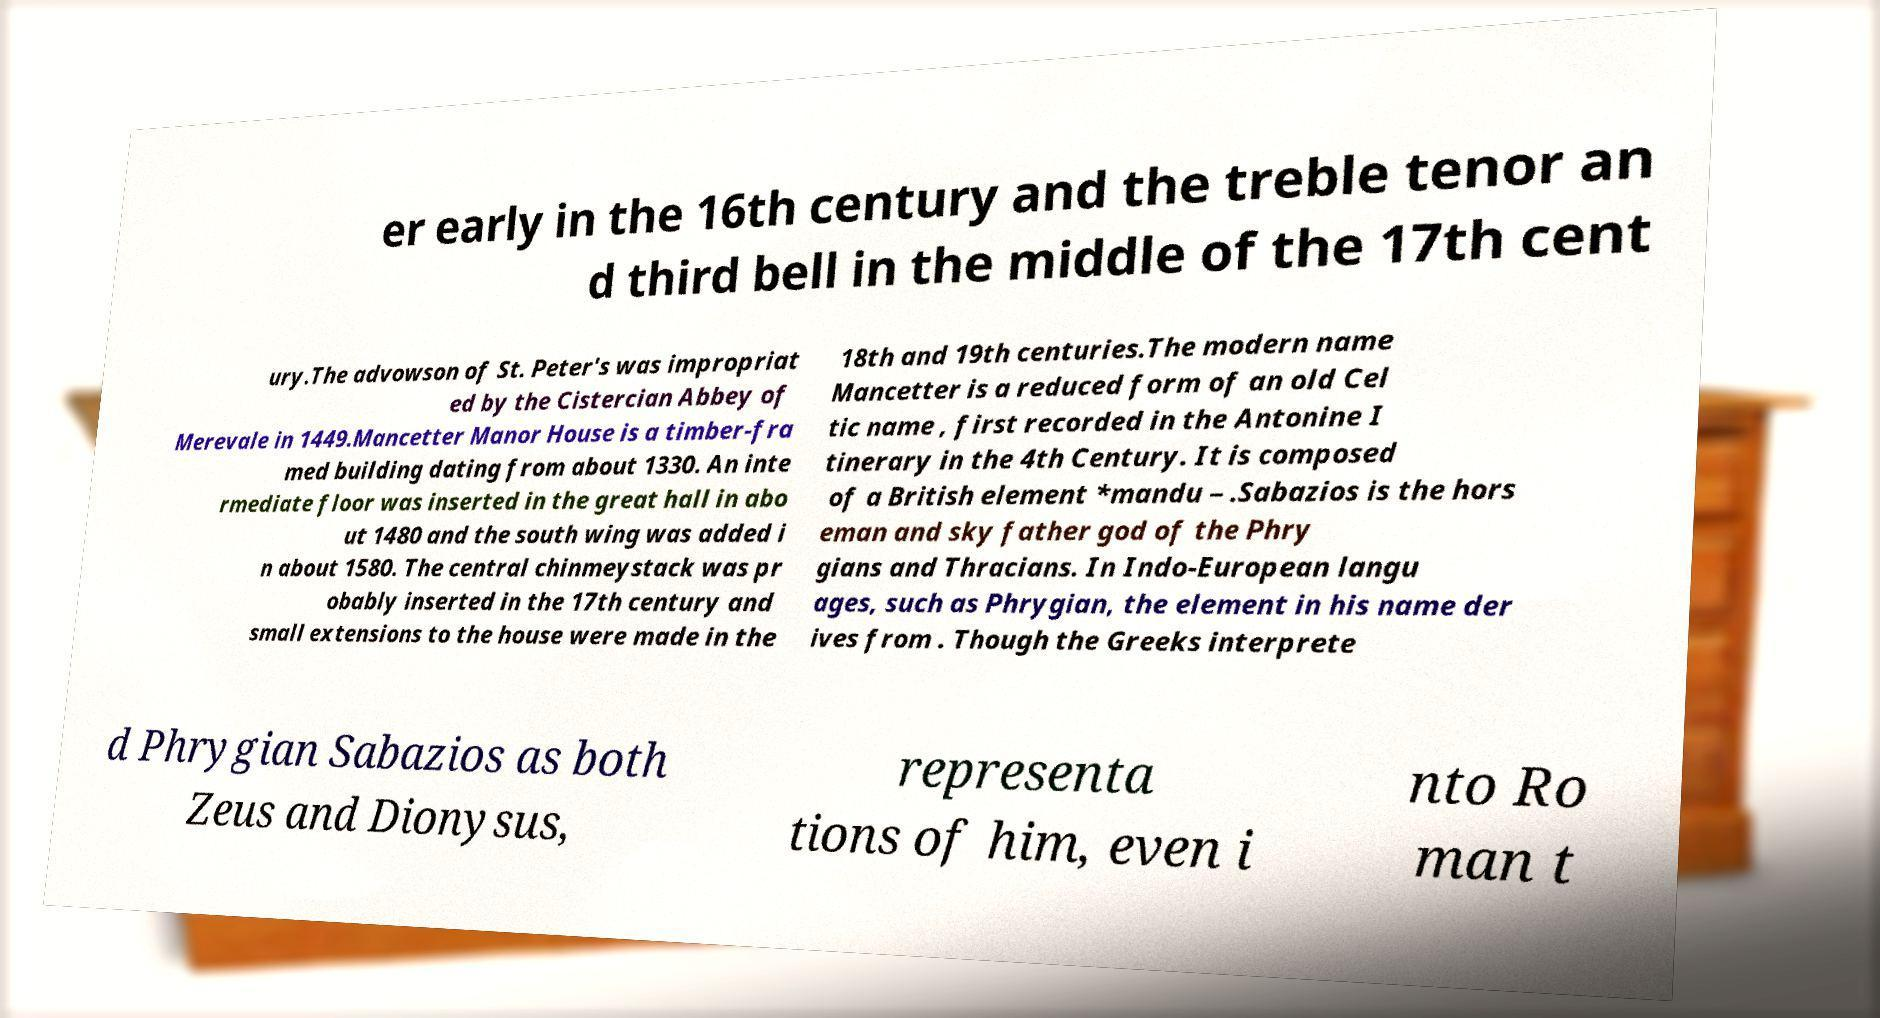I need the written content from this picture converted into text. Can you do that? er early in the 16th century and the treble tenor an d third bell in the middle of the 17th cent ury.The advowson of St. Peter's was impropriat ed by the Cistercian Abbey of Merevale in 1449.Mancetter Manor House is a timber-fra med building dating from about 1330. An inte rmediate floor was inserted in the great hall in abo ut 1480 and the south wing was added i n about 1580. The central chinmeystack was pr obably inserted in the 17th century and small extensions to the house were made in the 18th and 19th centuries.The modern name Mancetter is a reduced form of an old Cel tic name , first recorded in the Antonine I tinerary in the 4th Century. It is composed of a British element *mandu – .Sabazios is the hors eman and sky father god of the Phry gians and Thracians. In Indo-European langu ages, such as Phrygian, the element in his name der ives from . Though the Greeks interprete d Phrygian Sabazios as both Zeus and Dionysus, representa tions of him, even i nto Ro man t 